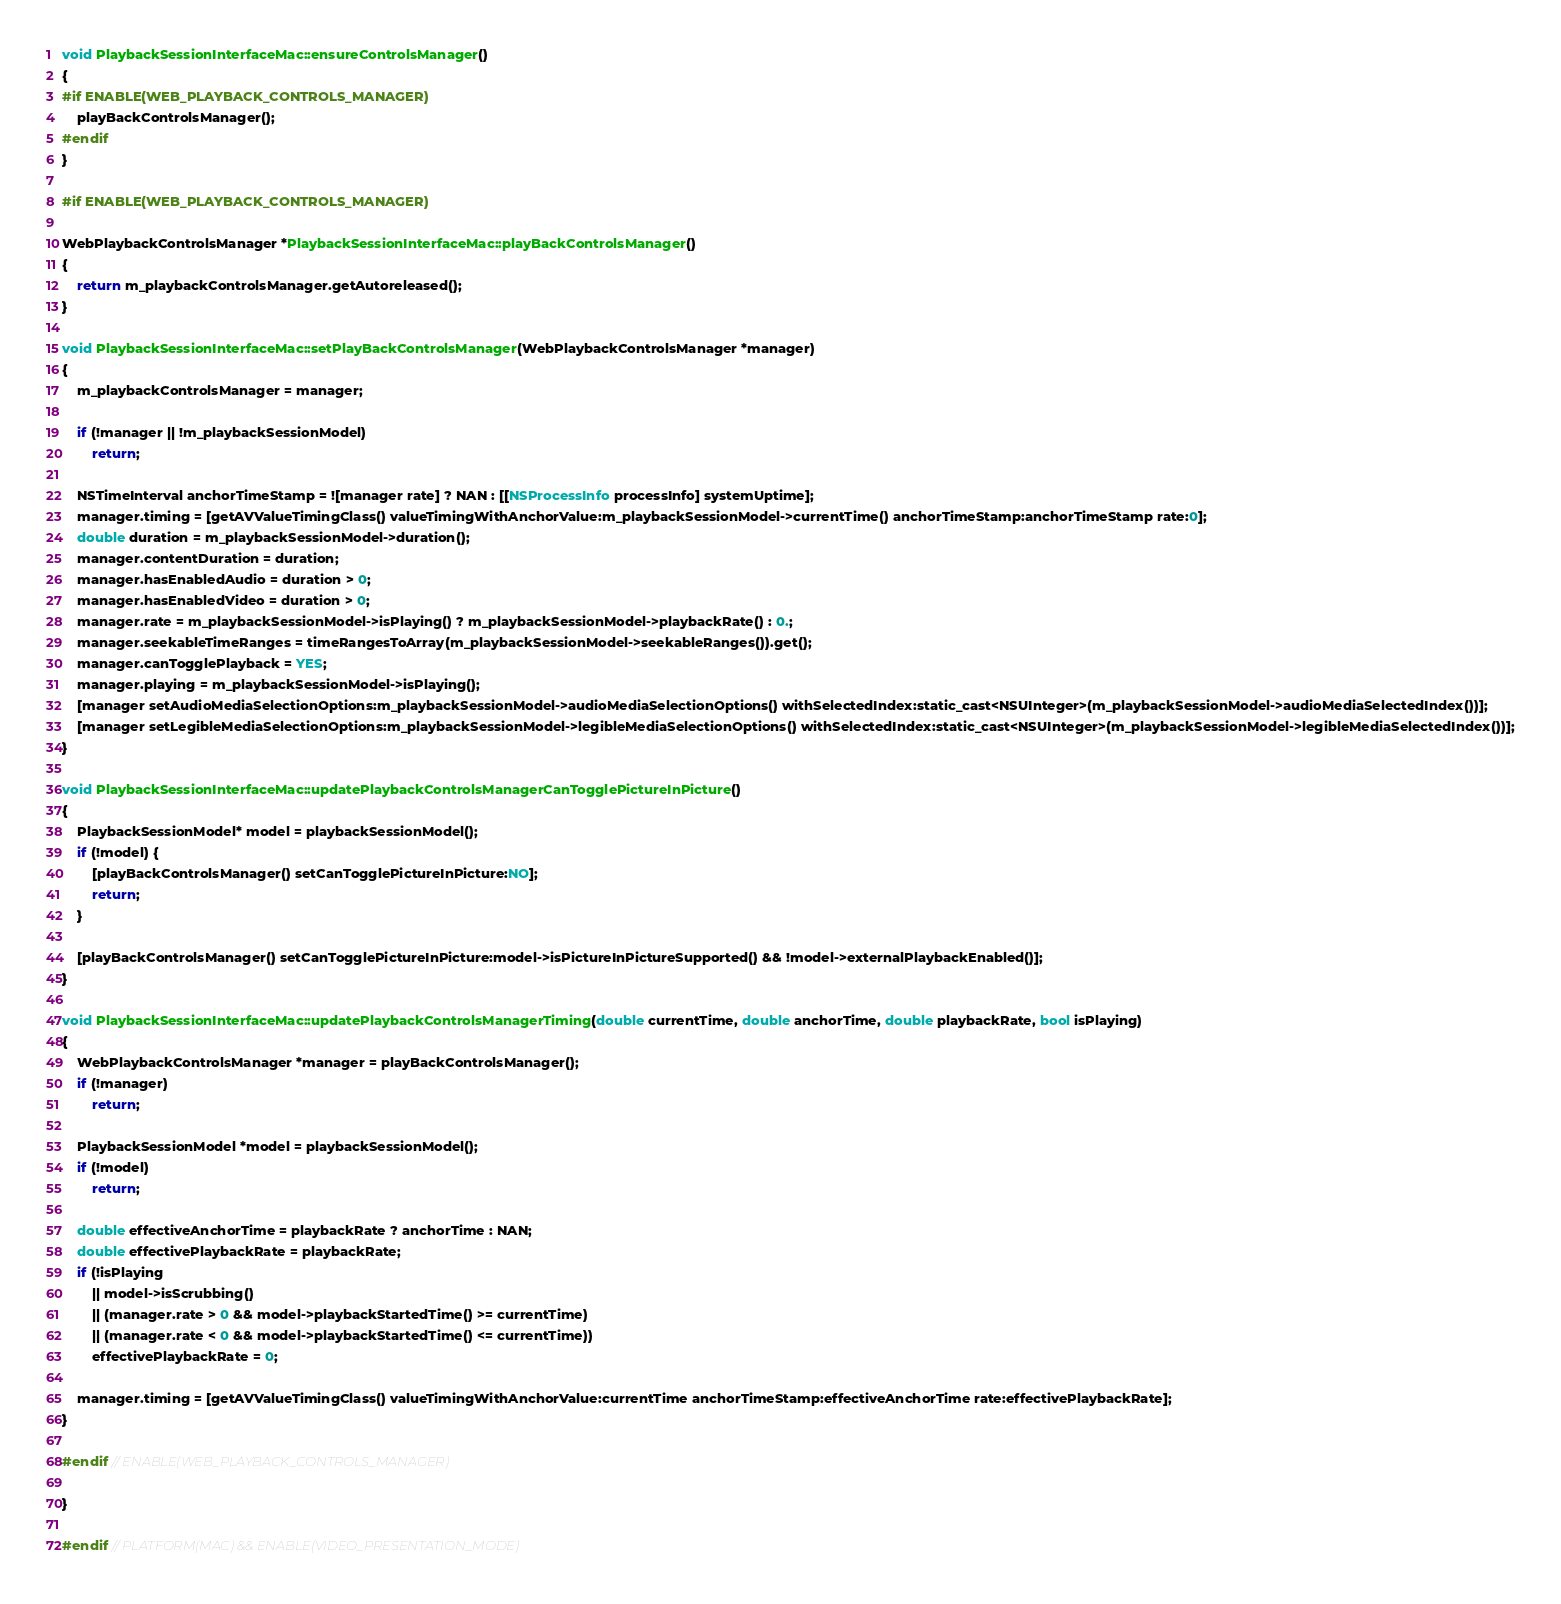Convert code to text. <code><loc_0><loc_0><loc_500><loc_500><_ObjectiveC_>
void PlaybackSessionInterfaceMac::ensureControlsManager()
{
#if ENABLE(WEB_PLAYBACK_CONTROLS_MANAGER)
    playBackControlsManager();
#endif
}

#if ENABLE(WEB_PLAYBACK_CONTROLS_MANAGER)

WebPlaybackControlsManager *PlaybackSessionInterfaceMac::playBackControlsManager()
{
    return m_playbackControlsManager.getAutoreleased();
}

void PlaybackSessionInterfaceMac::setPlayBackControlsManager(WebPlaybackControlsManager *manager)
{
    m_playbackControlsManager = manager;

    if (!manager || !m_playbackSessionModel)
        return;

    NSTimeInterval anchorTimeStamp = ![manager rate] ? NAN : [[NSProcessInfo processInfo] systemUptime];
    manager.timing = [getAVValueTimingClass() valueTimingWithAnchorValue:m_playbackSessionModel->currentTime() anchorTimeStamp:anchorTimeStamp rate:0];
    double duration = m_playbackSessionModel->duration();
    manager.contentDuration = duration;
    manager.hasEnabledAudio = duration > 0;
    manager.hasEnabledVideo = duration > 0;
    manager.rate = m_playbackSessionModel->isPlaying() ? m_playbackSessionModel->playbackRate() : 0.;
    manager.seekableTimeRanges = timeRangesToArray(m_playbackSessionModel->seekableRanges()).get();
    manager.canTogglePlayback = YES;
    manager.playing = m_playbackSessionModel->isPlaying();
    [manager setAudioMediaSelectionOptions:m_playbackSessionModel->audioMediaSelectionOptions() withSelectedIndex:static_cast<NSUInteger>(m_playbackSessionModel->audioMediaSelectedIndex())];
    [manager setLegibleMediaSelectionOptions:m_playbackSessionModel->legibleMediaSelectionOptions() withSelectedIndex:static_cast<NSUInteger>(m_playbackSessionModel->legibleMediaSelectedIndex())];
}

void PlaybackSessionInterfaceMac::updatePlaybackControlsManagerCanTogglePictureInPicture()
{
    PlaybackSessionModel* model = playbackSessionModel();
    if (!model) {
        [playBackControlsManager() setCanTogglePictureInPicture:NO];
        return;
    }

    [playBackControlsManager() setCanTogglePictureInPicture:model->isPictureInPictureSupported() && !model->externalPlaybackEnabled()];
}

void PlaybackSessionInterfaceMac::updatePlaybackControlsManagerTiming(double currentTime, double anchorTime, double playbackRate, bool isPlaying)
{
    WebPlaybackControlsManager *manager = playBackControlsManager();
    if (!manager)
        return;

    PlaybackSessionModel *model = playbackSessionModel();
    if (!model)
        return;

    double effectiveAnchorTime = playbackRate ? anchorTime : NAN;
    double effectivePlaybackRate = playbackRate;
    if (!isPlaying
        || model->isScrubbing()
        || (manager.rate > 0 && model->playbackStartedTime() >= currentTime)
        || (manager.rate < 0 && model->playbackStartedTime() <= currentTime))
        effectivePlaybackRate = 0;

    manager.timing = [getAVValueTimingClass() valueTimingWithAnchorValue:currentTime anchorTimeStamp:effectiveAnchorTime rate:effectivePlaybackRate];
}

#endif // ENABLE(WEB_PLAYBACK_CONTROLS_MANAGER)

}

#endif // PLATFORM(MAC) && ENABLE(VIDEO_PRESENTATION_MODE)
</code> 